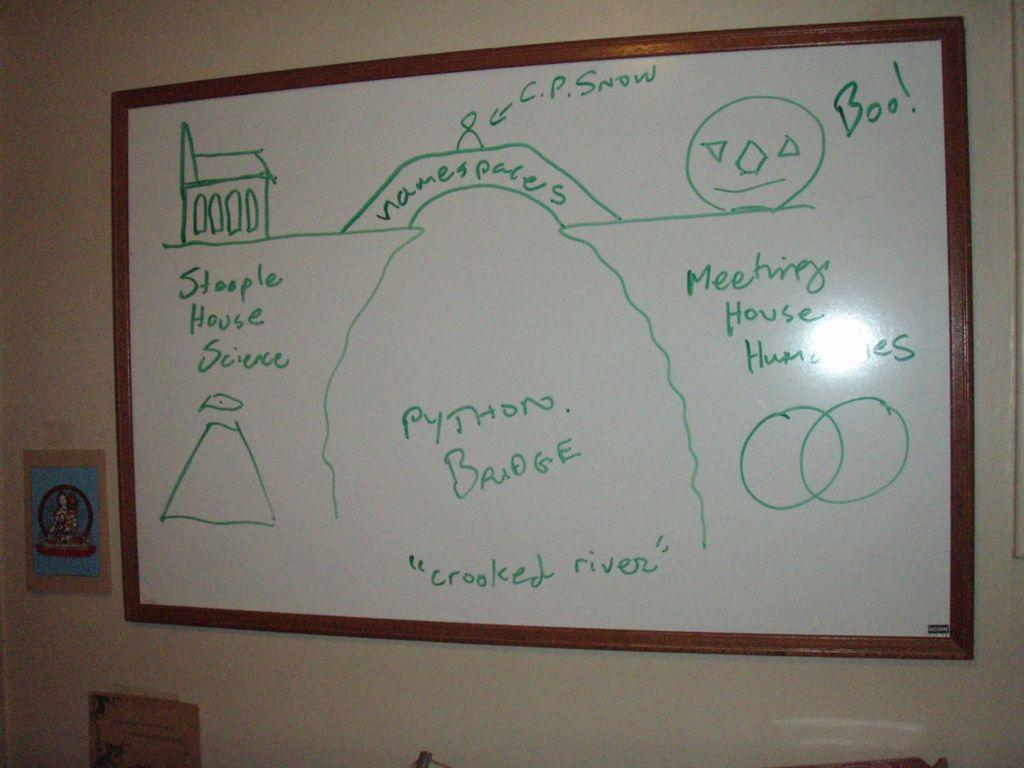What is the main object in the image? There is a whiteboard in the image. What else can be seen on the wall in the image? There are posters attached to the wall in the image. What type of bone is visible on the whiteboard in the image? There is no bone visible on the whiteboard in the image. What process is being depicted in the posters on the wall? The posters on the wall do not depict any specific process; they are simply attached to the wall. 